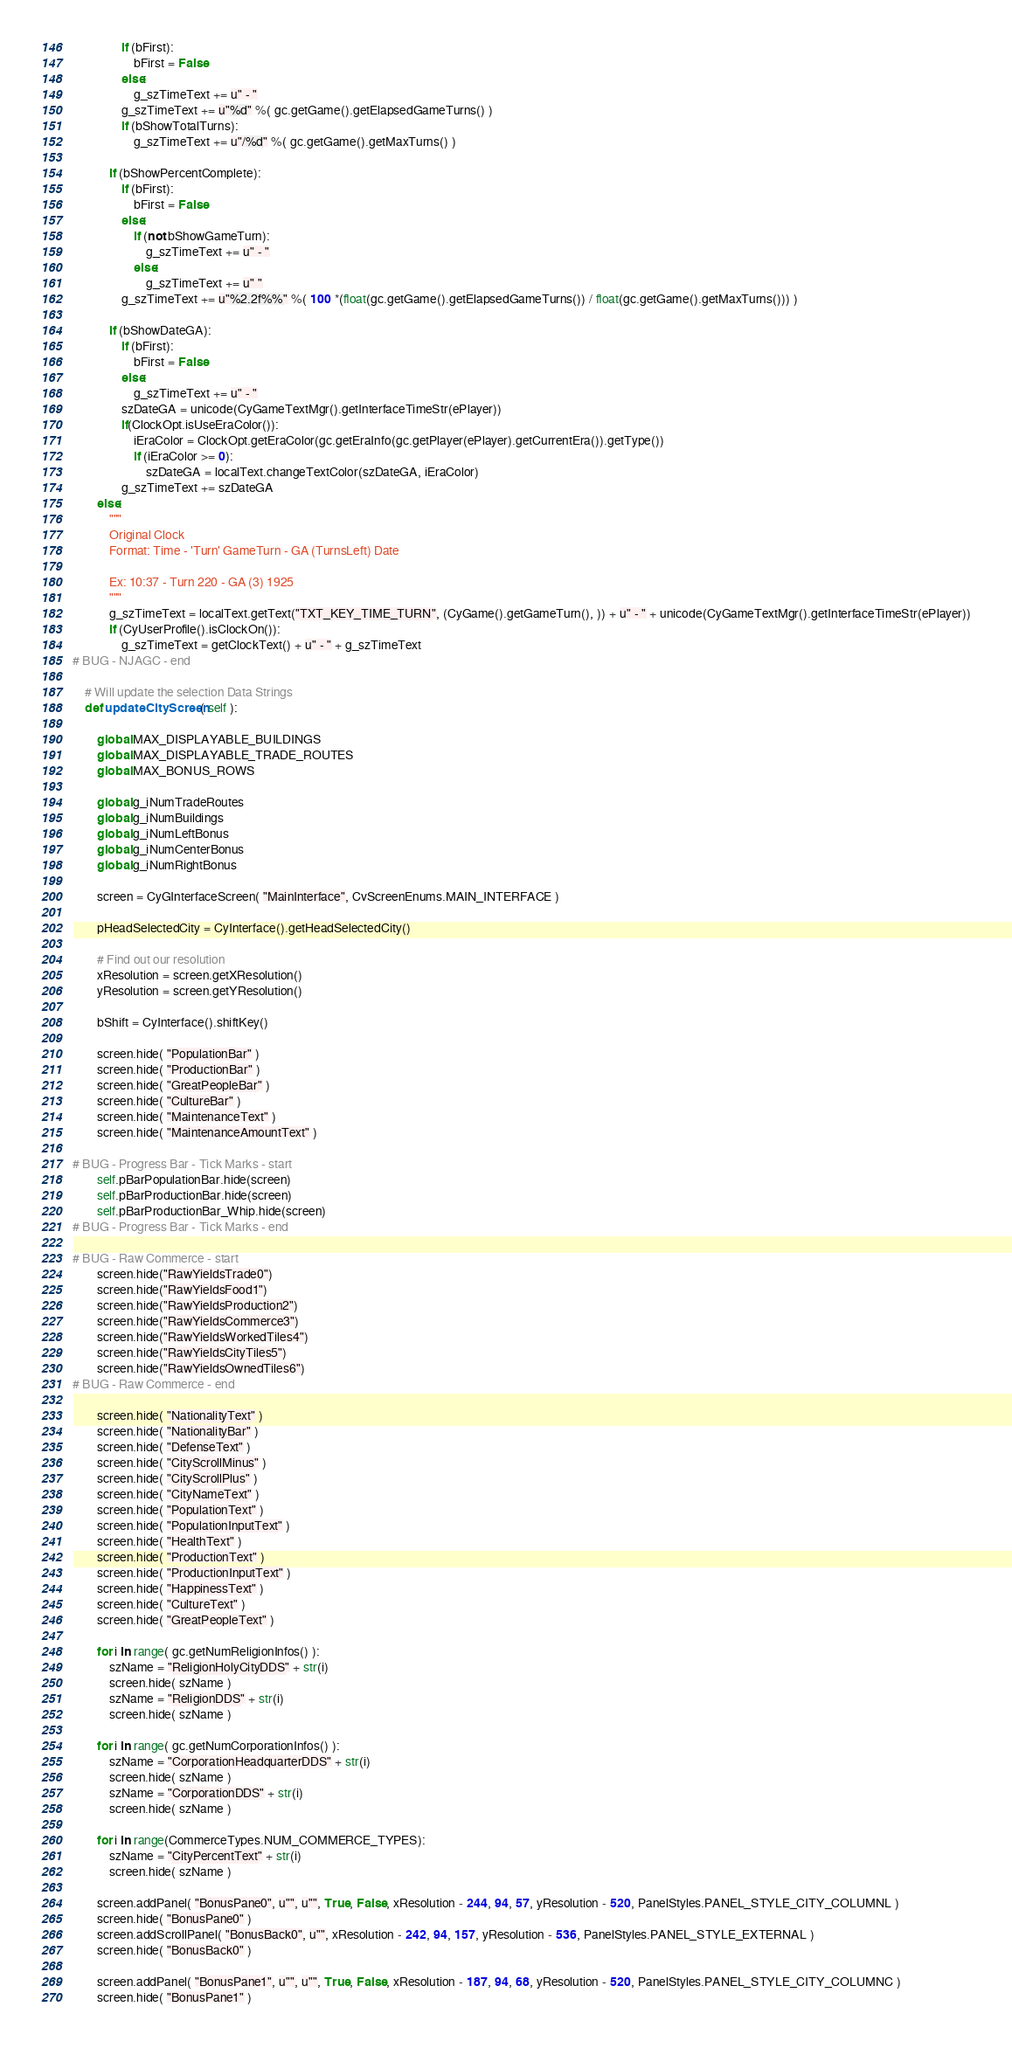<code> <loc_0><loc_0><loc_500><loc_500><_Python_>				if (bFirst):
					bFirst = False
				else:
					g_szTimeText += u" - "
				g_szTimeText += u"%d" %( gc.getGame().getElapsedGameTurns() )
				if (bShowTotalTurns):
					g_szTimeText += u"/%d" %( gc.getGame().getMaxTurns() )
			
			if (bShowPercentComplete):
				if (bFirst):
					bFirst = False
				else:
					if (not bShowGameTurn):
						g_szTimeText += u" - "
					else:
						g_szTimeText += u" "
				g_szTimeText += u"%2.2f%%" %( 100 *(float(gc.getGame().getElapsedGameTurns()) / float(gc.getGame().getMaxTurns())) )
			
			if (bShowDateGA):
				if (bFirst):
					bFirst = False
				else:
					g_szTimeText += u" - "
				szDateGA = unicode(CyGameTextMgr().getInterfaceTimeStr(ePlayer))
				if(ClockOpt.isUseEraColor()):
					iEraColor = ClockOpt.getEraColor(gc.getEraInfo(gc.getPlayer(ePlayer).getCurrentEra()).getType())
					if (iEraColor >= 0):
						szDateGA = localText.changeTextColor(szDateGA, iEraColor)
				g_szTimeText += szDateGA
		else:
			"""
			Original Clock
			Format: Time - 'Turn' GameTurn - GA (TurnsLeft) Date
			
			Ex: 10:37 - Turn 220 - GA (3) 1925
			"""
			g_szTimeText = localText.getText("TXT_KEY_TIME_TURN", (CyGame().getGameTurn(), )) + u" - " + unicode(CyGameTextMgr().getInterfaceTimeStr(ePlayer))
			if (CyUserProfile().isClockOn()):
				g_szTimeText = getClockText() + u" - " + g_szTimeText
# BUG - NJAGC - end
		
	# Will update the selection Data Strings
	def updateCityScreen( self ):
	
		global MAX_DISPLAYABLE_BUILDINGS
		global MAX_DISPLAYABLE_TRADE_ROUTES
		global MAX_BONUS_ROWS
		
		global g_iNumTradeRoutes
		global g_iNumBuildings
		global g_iNumLeftBonus
		global g_iNumCenterBonus
		global g_iNumRightBonus
	
		screen = CyGInterfaceScreen( "MainInterface", CvScreenEnums.MAIN_INTERFACE )

		pHeadSelectedCity = CyInterface().getHeadSelectedCity()

		# Find out our resolution
		xResolution = screen.getXResolution()
		yResolution = screen.getYResolution()

		bShift = CyInterface().shiftKey()

		screen.hide( "PopulationBar" )
		screen.hide( "ProductionBar" )
		screen.hide( "GreatPeopleBar" )
		screen.hide( "CultureBar" )
		screen.hide( "MaintenanceText" )
		screen.hide( "MaintenanceAmountText" )

# BUG - Progress Bar - Tick Marks - start
		self.pBarPopulationBar.hide(screen)
		self.pBarProductionBar.hide(screen)
		self.pBarProductionBar_Whip.hide(screen)
# BUG - Progress Bar - Tick Marks - end

# BUG - Raw Commerce - start
		screen.hide("RawYieldsTrade0")
		screen.hide("RawYieldsFood1")
		screen.hide("RawYieldsProduction2")
		screen.hide("RawYieldsCommerce3")
		screen.hide("RawYieldsWorkedTiles4")
		screen.hide("RawYieldsCityTiles5")
		screen.hide("RawYieldsOwnedTiles6")
# BUG - Raw Commerce - end
		
		screen.hide( "NationalityText" )
		screen.hide( "NationalityBar" )
		screen.hide( "DefenseText" )
		screen.hide( "CityScrollMinus" )
		screen.hide( "CityScrollPlus" )
		screen.hide( "CityNameText" )
		screen.hide( "PopulationText" )
		screen.hide( "PopulationInputText" )
		screen.hide( "HealthText" )
		screen.hide( "ProductionText" )
		screen.hide( "ProductionInputText" )
		screen.hide( "HappinessText" )
		screen.hide( "CultureText" )
		screen.hide( "GreatPeopleText" )

		for i in range( gc.getNumReligionInfos() ):
			szName = "ReligionHolyCityDDS" + str(i)
			screen.hide( szName )
			szName = "ReligionDDS" + str(i)
			screen.hide( szName )
			
		for i in range( gc.getNumCorporationInfos() ):
			szName = "CorporationHeadquarterDDS" + str(i)
			screen.hide( szName )
			szName = "CorporationDDS" + str(i)
			screen.hide( szName )
			
		for i in range(CommerceTypes.NUM_COMMERCE_TYPES):
			szName = "CityPercentText" + str(i)
			screen.hide( szName )

		screen.addPanel( "BonusPane0", u"", u"", True, False, xResolution - 244, 94, 57, yResolution - 520, PanelStyles.PANEL_STYLE_CITY_COLUMNL )
		screen.hide( "BonusPane0" )
		screen.addScrollPanel( "BonusBack0", u"", xResolution - 242, 94, 157, yResolution - 536, PanelStyles.PANEL_STYLE_EXTERNAL )
		screen.hide( "BonusBack0" )

		screen.addPanel( "BonusPane1", u"", u"", True, False, xResolution - 187, 94, 68, yResolution - 520, PanelStyles.PANEL_STYLE_CITY_COLUMNC )
		screen.hide( "BonusPane1" )</code> 